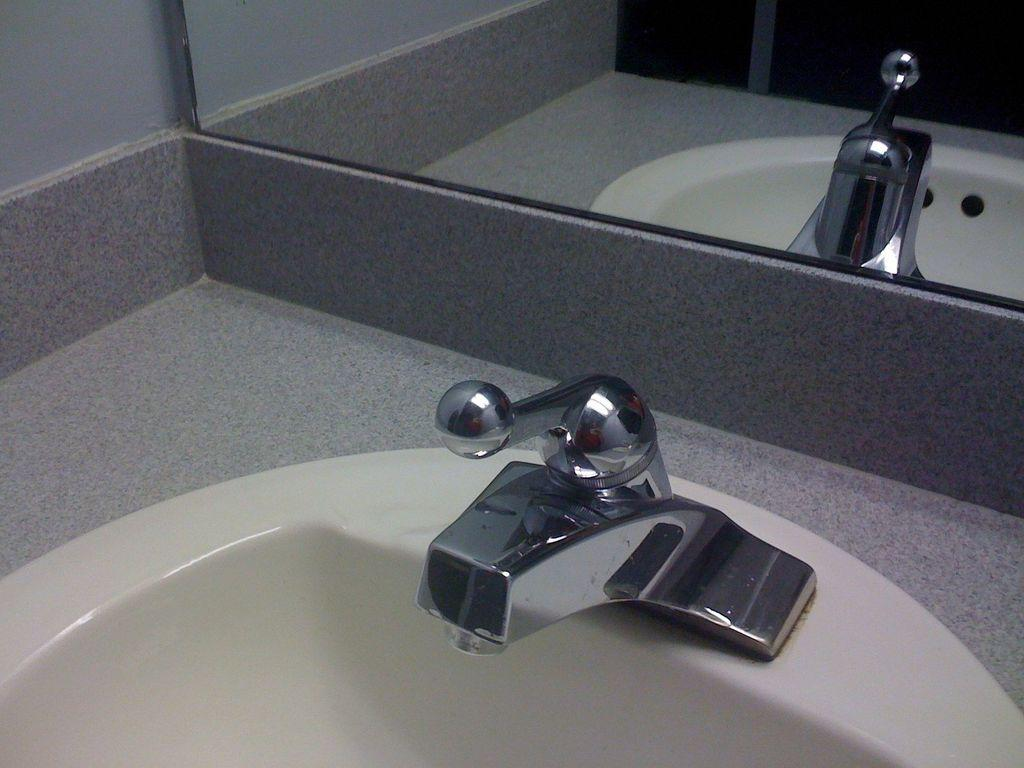What can be found in the image that is used for washing hands? There is a wash basin in the image that can be used for washing hands. What feature does the wash basin have? The wash basin has a tap. What is another object present in the image that is commonly found in bathrooms? There is a mirror in the image. What does the mirror show in the image? The mirror reflects the wash basin. What type of zinc is visible in the image? There is no zinc present in the image. Can you see the person's mom in the image? There is no person or mom present in the image. 